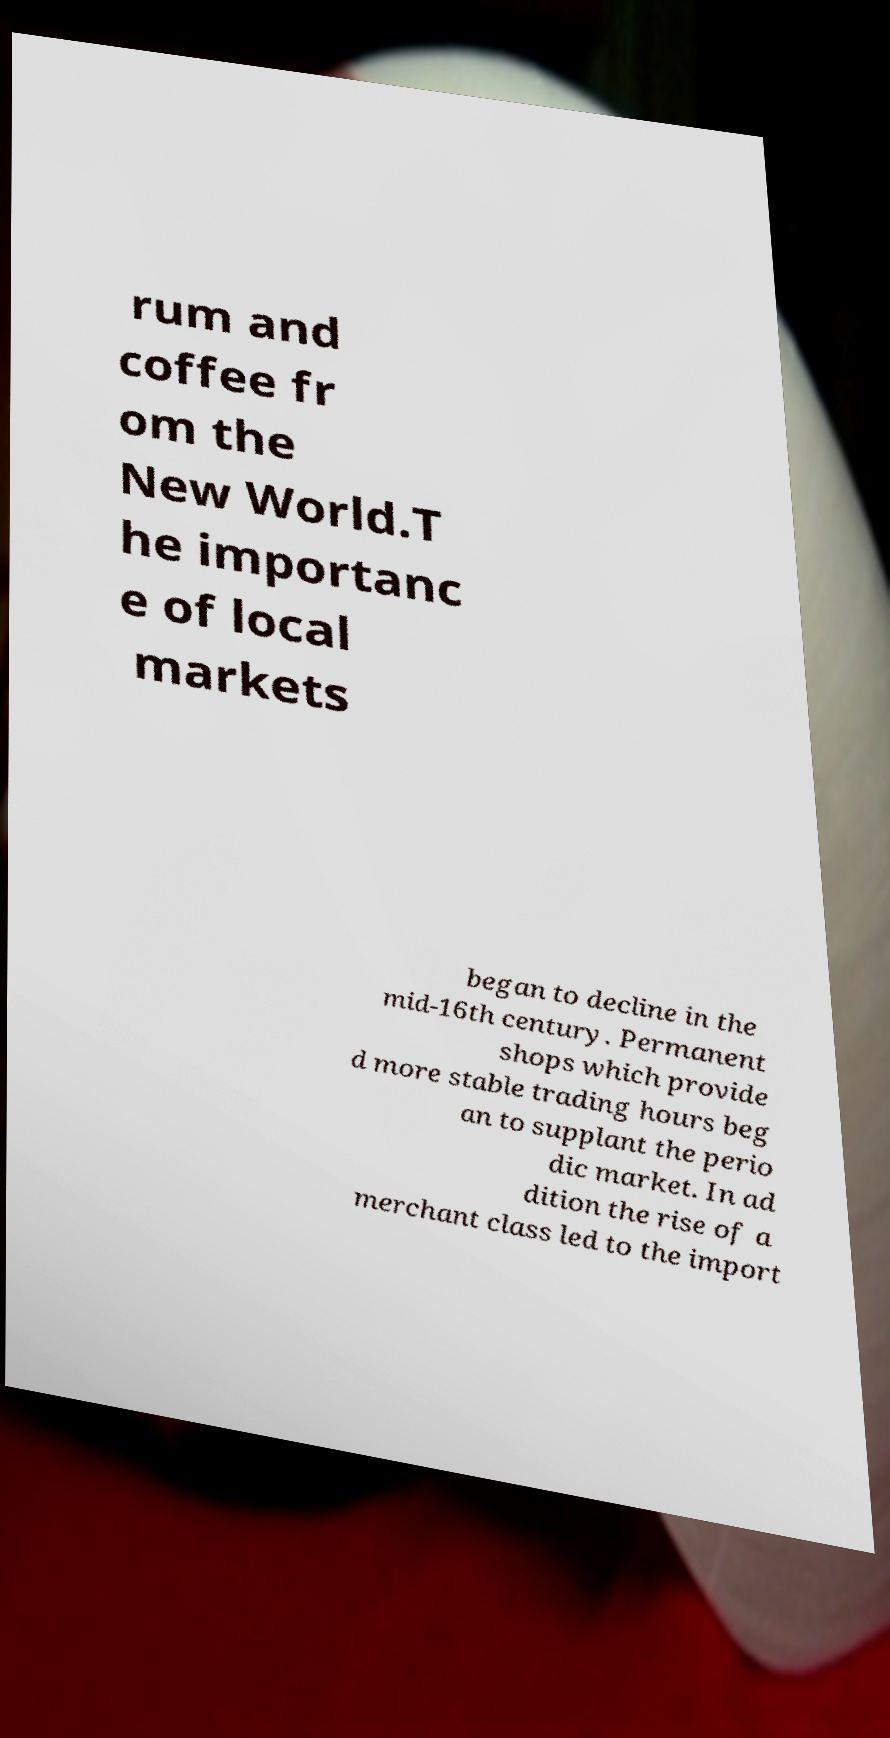For documentation purposes, I need the text within this image transcribed. Could you provide that? rum and coffee fr om the New World.T he importanc e of local markets began to decline in the mid-16th century. Permanent shops which provide d more stable trading hours beg an to supplant the perio dic market. In ad dition the rise of a merchant class led to the import 